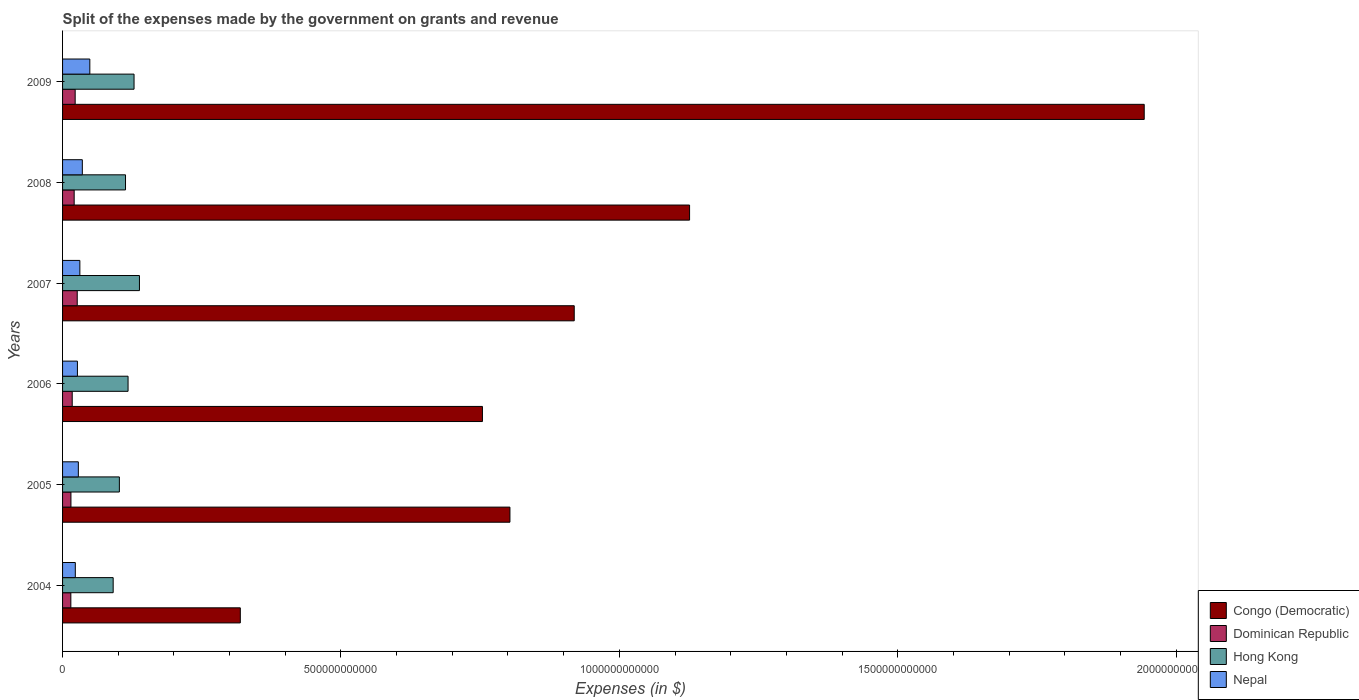How many different coloured bars are there?
Your answer should be compact. 4. How many groups of bars are there?
Provide a short and direct response. 6. How many bars are there on the 1st tick from the top?
Ensure brevity in your answer.  4. How many bars are there on the 6th tick from the bottom?
Your answer should be compact. 4. In how many cases, is the number of bars for a given year not equal to the number of legend labels?
Provide a short and direct response. 0. What is the expenses made by the government on grants and revenue in Nepal in 2009?
Your answer should be very brief. 4.90e+1. Across all years, what is the maximum expenses made by the government on grants and revenue in Congo (Democratic)?
Make the answer very short. 1.94e+12. Across all years, what is the minimum expenses made by the government on grants and revenue in Dominican Republic?
Ensure brevity in your answer.  1.49e+1. In which year was the expenses made by the government on grants and revenue in Hong Kong maximum?
Offer a terse response. 2007. What is the total expenses made by the government on grants and revenue in Hong Kong in the graph?
Provide a succinct answer. 6.90e+11. What is the difference between the expenses made by the government on grants and revenue in Nepal in 2006 and that in 2007?
Your answer should be very brief. -4.39e+09. What is the difference between the expenses made by the government on grants and revenue in Dominican Republic in 2006 and the expenses made by the government on grants and revenue in Congo (Democratic) in 2008?
Offer a terse response. -1.11e+12. What is the average expenses made by the government on grants and revenue in Dominican Republic per year?
Ensure brevity in your answer.  1.95e+1. In the year 2006, what is the difference between the expenses made by the government on grants and revenue in Nepal and expenses made by the government on grants and revenue in Hong Kong?
Keep it short and to the point. -9.10e+1. In how many years, is the expenses made by the government on grants and revenue in Hong Kong greater than 1100000000000 $?
Keep it short and to the point. 0. What is the ratio of the expenses made by the government on grants and revenue in Dominican Republic in 2005 to that in 2008?
Keep it short and to the point. 0.72. What is the difference between the highest and the second highest expenses made by the government on grants and revenue in Nepal?
Offer a terse response. 1.35e+1. What is the difference between the highest and the lowest expenses made by the government on grants and revenue in Nepal?
Offer a terse response. 2.61e+1. Is the sum of the expenses made by the government on grants and revenue in Dominican Republic in 2004 and 2005 greater than the maximum expenses made by the government on grants and revenue in Congo (Democratic) across all years?
Ensure brevity in your answer.  No. What does the 1st bar from the top in 2009 represents?
Ensure brevity in your answer.  Nepal. What does the 3rd bar from the bottom in 2007 represents?
Ensure brevity in your answer.  Hong Kong. Is it the case that in every year, the sum of the expenses made by the government on grants and revenue in Dominican Republic and expenses made by the government on grants and revenue in Nepal is greater than the expenses made by the government on grants and revenue in Congo (Democratic)?
Provide a short and direct response. No. How many bars are there?
Keep it short and to the point. 24. Are all the bars in the graph horizontal?
Your answer should be very brief. Yes. What is the difference between two consecutive major ticks on the X-axis?
Offer a terse response. 5.00e+11. Does the graph contain any zero values?
Your answer should be compact. No. Where does the legend appear in the graph?
Keep it short and to the point. Bottom right. What is the title of the graph?
Keep it short and to the point. Split of the expenses made by the government on grants and revenue. What is the label or title of the X-axis?
Provide a short and direct response. Expenses (in $). What is the Expenses (in $) in Congo (Democratic) in 2004?
Ensure brevity in your answer.  3.19e+11. What is the Expenses (in $) of Dominican Republic in 2004?
Provide a succinct answer. 1.49e+1. What is the Expenses (in $) in Hong Kong in 2004?
Offer a very short reply. 9.09e+1. What is the Expenses (in $) in Nepal in 2004?
Offer a very short reply. 2.29e+1. What is the Expenses (in $) in Congo (Democratic) in 2005?
Provide a short and direct response. 8.04e+11. What is the Expenses (in $) of Dominican Republic in 2005?
Keep it short and to the point. 1.50e+1. What is the Expenses (in $) in Hong Kong in 2005?
Ensure brevity in your answer.  1.02e+11. What is the Expenses (in $) in Nepal in 2005?
Keep it short and to the point. 2.84e+1. What is the Expenses (in $) in Congo (Democratic) in 2006?
Provide a succinct answer. 7.54e+11. What is the Expenses (in $) of Dominican Republic in 2006?
Provide a succinct answer. 1.73e+1. What is the Expenses (in $) in Hong Kong in 2006?
Give a very brief answer. 1.18e+11. What is the Expenses (in $) in Nepal in 2006?
Give a very brief answer. 2.67e+1. What is the Expenses (in $) in Congo (Democratic) in 2007?
Provide a succinct answer. 9.19e+11. What is the Expenses (in $) of Dominican Republic in 2007?
Your answer should be very brief. 2.64e+1. What is the Expenses (in $) of Hong Kong in 2007?
Offer a terse response. 1.38e+11. What is the Expenses (in $) of Nepal in 2007?
Your response must be concise. 3.11e+1. What is the Expenses (in $) of Congo (Democratic) in 2008?
Ensure brevity in your answer.  1.13e+12. What is the Expenses (in $) in Dominican Republic in 2008?
Provide a succinct answer. 2.09e+1. What is the Expenses (in $) of Hong Kong in 2008?
Make the answer very short. 1.13e+11. What is the Expenses (in $) of Nepal in 2008?
Make the answer very short. 3.55e+1. What is the Expenses (in $) in Congo (Democratic) in 2009?
Make the answer very short. 1.94e+12. What is the Expenses (in $) in Dominican Republic in 2009?
Your response must be concise. 2.26e+1. What is the Expenses (in $) in Hong Kong in 2009?
Provide a short and direct response. 1.28e+11. What is the Expenses (in $) in Nepal in 2009?
Provide a short and direct response. 4.90e+1. Across all years, what is the maximum Expenses (in $) in Congo (Democratic)?
Your response must be concise. 1.94e+12. Across all years, what is the maximum Expenses (in $) of Dominican Republic?
Give a very brief answer. 2.64e+1. Across all years, what is the maximum Expenses (in $) of Hong Kong?
Offer a terse response. 1.38e+11. Across all years, what is the maximum Expenses (in $) in Nepal?
Your answer should be compact. 4.90e+1. Across all years, what is the minimum Expenses (in $) of Congo (Democratic)?
Keep it short and to the point. 3.19e+11. Across all years, what is the minimum Expenses (in $) of Dominican Republic?
Offer a very short reply. 1.49e+1. Across all years, what is the minimum Expenses (in $) of Hong Kong?
Your answer should be compact. 9.09e+1. Across all years, what is the minimum Expenses (in $) of Nepal?
Offer a very short reply. 2.29e+1. What is the total Expenses (in $) in Congo (Democratic) in the graph?
Offer a very short reply. 5.86e+12. What is the total Expenses (in $) in Dominican Republic in the graph?
Provide a succinct answer. 1.17e+11. What is the total Expenses (in $) of Hong Kong in the graph?
Provide a short and direct response. 6.90e+11. What is the total Expenses (in $) of Nepal in the graph?
Give a very brief answer. 1.93e+11. What is the difference between the Expenses (in $) in Congo (Democratic) in 2004 and that in 2005?
Offer a very short reply. -4.84e+11. What is the difference between the Expenses (in $) of Dominican Republic in 2004 and that in 2005?
Make the answer very short. -1.70e+08. What is the difference between the Expenses (in $) in Hong Kong in 2004 and that in 2005?
Keep it short and to the point. -1.11e+1. What is the difference between the Expenses (in $) in Nepal in 2004 and that in 2005?
Offer a terse response. -5.46e+09. What is the difference between the Expenses (in $) of Congo (Democratic) in 2004 and that in 2006?
Provide a short and direct response. -4.35e+11. What is the difference between the Expenses (in $) of Dominican Republic in 2004 and that in 2006?
Make the answer very short. -2.48e+09. What is the difference between the Expenses (in $) of Hong Kong in 2004 and that in 2006?
Provide a succinct answer. -2.67e+1. What is the difference between the Expenses (in $) of Nepal in 2004 and that in 2006?
Ensure brevity in your answer.  -3.78e+09. What is the difference between the Expenses (in $) of Congo (Democratic) in 2004 and that in 2007?
Keep it short and to the point. -6.00e+11. What is the difference between the Expenses (in $) of Dominican Republic in 2004 and that in 2007?
Your answer should be compact. -1.15e+1. What is the difference between the Expenses (in $) of Hong Kong in 2004 and that in 2007?
Offer a very short reply. -4.72e+1. What is the difference between the Expenses (in $) in Nepal in 2004 and that in 2007?
Your response must be concise. -8.17e+09. What is the difference between the Expenses (in $) in Congo (Democratic) in 2004 and that in 2008?
Ensure brevity in your answer.  -8.07e+11. What is the difference between the Expenses (in $) in Dominican Republic in 2004 and that in 2008?
Ensure brevity in your answer.  -5.98e+09. What is the difference between the Expenses (in $) of Hong Kong in 2004 and that in 2008?
Offer a very short reply. -2.22e+1. What is the difference between the Expenses (in $) in Nepal in 2004 and that in 2008?
Provide a short and direct response. -1.26e+1. What is the difference between the Expenses (in $) in Congo (Democratic) in 2004 and that in 2009?
Ensure brevity in your answer.  -1.62e+12. What is the difference between the Expenses (in $) in Dominican Republic in 2004 and that in 2009?
Provide a short and direct response. -7.78e+09. What is the difference between the Expenses (in $) in Hong Kong in 2004 and that in 2009?
Ensure brevity in your answer.  -3.75e+1. What is the difference between the Expenses (in $) of Nepal in 2004 and that in 2009?
Provide a short and direct response. -2.61e+1. What is the difference between the Expenses (in $) in Congo (Democratic) in 2005 and that in 2006?
Your answer should be compact. 4.94e+1. What is the difference between the Expenses (in $) of Dominican Republic in 2005 and that in 2006?
Your answer should be compact. -2.31e+09. What is the difference between the Expenses (in $) in Hong Kong in 2005 and that in 2006?
Give a very brief answer. -1.56e+1. What is the difference between the Expenses (in $) of Nepal in 2005 and that in 2006?
Give a very brief answer. 1.68e+09. What is the difference between the Expenses (in $) of Congo (Democratic) in 2005 and that in 2007?
Your response must be concise. -1.15e+11. What is the difference between the Expenses (in $) in Dominican Republic in 2005 and that in 2007?
Offer a terse response. -1.13e+1. What is the difference between the Expenses (in $) in Hong Kong in 2005 and that in 2007?
Provide a succinct answer. -3.61e+1. What is the difference between the Expenses (in $) of Nepal in 2005 and that in 2007?
Make the answer very short. -2.71e+09. What is the difference between the Expenses (in $) of Congo (Democratic) in 2005 and that in 2008?
Provide a succinct answer. -3.23e+11. What is the difference between the Expenses (in $) of Dominican Republic in 2005 and that in 2008?
Provide a succinct answer. -5.81e+09. What is the difference between the Expenses (in $) of Hong Kong in 2005 and that in 2008?
Provide a succinct answer. -1.11e+1. What is the difference between the Expenses (in $) of Nepal in 2005 and that in 2008?
Make the answer very short. -7.14e+09. What is the difference between the Expenses (in $) in Congo (Democratic) in 2005 and that in 2009?
Provide a short and direct response. -1.14e+12. What is the difference between the Expenses (in $) of Dominican Republic in 2005 and that in 2009?
Provide a short and direct response. -7.61e+09. What is the difference between the Expenses (in $) of Hong Kong in 2005 and that in 2009?
Ensure brevity in your answer.  -2.64e+1. What is the difference between the Expenses (in $) in Nepal in 2005 and that in 2009?
Ensure brevity in your answer.  -2.06e+1. What is the difference between the Expenses (in $) of Congo (Democratic) in 2006 and that in 2007?
Keep it short and to the point. -1.65e+11. What is the difference between the Expenses (in $) of Dominican Republic in 2006 and that in 2007?
Your answer should be compact. -9.00e+09. What is the difference between the Expenses (in $) of Hong Kong in 2006 and that in 2007?
Your answer should be very brief. -2.05e+1. What is the difference between the Expenses (in $) of Nepal in 2006 and that in 2007?
Ensure brevity in your answer.  -4.39e+09. What is the difference between the Expenses (in $) in Congo (Democratic) in 2006 and that in 2008?
Provide a succinct answer. -3.72e+11. What is the difference between the Expenses (in $) in Dominican Republic in 2006 and that in 2008?
Your response must be concise. -3.50e+09. What is the difference between the Expenses (in $) of Hong Kong in 2006 and that in 2008?
Offer a very short reply. 4.56e+09. What is the difference between the Expenses (in $) of Nepal in 2006 and that in 2008?
Provide a short and direct response. -8.82e+09. What is the difference between the Expenses (in $) of Congo (Democratic) in 2006 and that in 2009?
Your response must be concise. -1.19e+12. What is the difference between the Expenses (in $) in Dominican Republic in 2006 and that in 2009?
Ensure brevity in your answer.  -5.30e+09. What is the difference between the Expenses (in $) in Hong Kong in 2006 and that in 2009?
Your response must be concise. -1.07e+1. What is the difference between the Expenses (in $) in Nepal in 2006 and that in 2009?
Your answer should be compact. -2.23e+1. What is the difference between the Expenses (in $) in Congo (Democratic) in 2007 and that in 2008?
Give a very brief answer. -2.07e+11. What is the difference between the Expenses (in $) in Dominican Republic in 2007 and that in 2008?
Give a very brief answer. 5.50e+09. What is the difference between the Expenses (in $) in Hong Kong in 2007 and that in 2008?
Provide a short and direct response. 2.50e+1. What is the difference between the Expenses (in $) in Nepal in 2007 and that in 2008?
Your answer should be very brief. -4.43e+09. What is the difference between the Expenses (in $) in Congo (Democratic) in 2007 and that in 2009?
Keep it short and to the point. -1.02e+12. What is the difference between the Expenses (in $) of Dominican Republic in 2007 and that in 2009?
Ensure brevity in your answer.  3.70e+09. What is the difference between the Expenses (in $) in Hong Kong in 2007 and that in 2009?
Make the answer very short. 9.71e+09. What is the difference between the Expenses (in $) of Nepal in 2007 and that in 2009?
Offer a terse response. -1.79e+1. What is the difference between the Expenses (in $) in Congo (Democratic) in 2008 and that in 2009?
Give a very brief answer. -8.17e+11. What is the difference between the Expenses (in $) in Dominican Republic in 2008 and that in 2009?
Ensure brevity in your answer.  -1.80e+09. What is the difference between the Expenses (in $) of Hong Kong in 2008 and that in 2009?
Provide a succinct answer. -1.53e+1. What is the difference between the Expenses (in $) in Nepal in 2008 and that in 2009?
Your answer should be compact. -1.35e+1. What is the difference between the Expenses (in $) of Congo (Democratic) in 2004 and the Expenses (in $) of Dominican Republic in 2005?
Your answer should be compact. 3.04e+11. What is the difference between the Expenses (in $) in Congo (Democratic) in 2004 and the Expenses (in $) in Hong Kong in 2005?
Your response must be concise. 2.17e+11. What is the difference between the Expenses (in $) in Congo (Democratic) in 2004 and the Expenses (in $) in Nepal in 2005?
Your answer should be very brief. 2.91e+11. What is the difference between the Expenses (in $) of Dominican Republic in 2004 and the Expenses (in $) of Hong Kong in 2005?
Your response must be concise. -8.72e+1. What is the difference between the Expenses (in $) of Dominican Republic in 2004 and the Expenses (in $) of Nepal in 2005?
Keep it short and to the point. -1.35e+1. What is the difference between the Expenses (in $) of Hong Kong in 2004 and the Expenses (in $) of Nepal in 2005?
Provide a succinct answer. 6.26e+1. What is the difference between the Expenses (in $) of Congo (Democratic) in 2004 and the Expenses (in $) of Dominican Republic in 2006?
Keep it short and to the point. 3.02e+11. What is the difference between the Expenses (in $) of Congo (Democratic) in 2004 and the Expenses (in $) of Hong Kong in 2006?
Your answer should be very brief. 2.02e+11. What is the difference between the Expenses (in $) in Congo (Democratic) in 2004 and the Expenses (in $) in Nepal in 2006?
Offer a very short reply. 2.93e+11. What is the difference between the Expenses (in $) of Dominican Republic in 2004 and the Expenses (in $) of Hong Kong in 2006?
Your answer should be compact. -1.03e+11. What is the difference between the Expenses (in $) in Dominican Republic in 2004 and the Expenses (in $) in Nepal in 2006?
Provide a short and direct response. -1.18e+1. What is the difference between the Expenses (in $) in Hong Kong in 2004 and the Expenses (in $) in Nepal in 2006?
Your answer should be compact. 6.42e+1. What is the difference between the Expenses (in $) in Congo (Democratic) in 2004 and the Expenses (in $) in Dominican Republic in 2007?
Offer a very short reply. 2.93e+11. What is the difference between the Expenses (in $) of Congo (Democratic) in 2004 and the Expenses (in $) of Hong Kong in 2007?
Give a very brief answer. 1.81e+11. What is the difference between the Expenses (in $) in Congo (Democratic) in 2004 and the Expenses (in $) in Nepal in 2007?
Your answer should be compact. 2.88e+11. What is the difference between the Expenses (in $) in Dominican Republic in 2004 and the Expenses (in $) in Hong Kong in 2007?
Your response must be concise. -1.23e+11. What is the difference between the Expenses (in $) in Dominican Republic in 2004 and the Expenses (in $) in Nepal in 2007?
Ensure brevity in your answer.  -1.62e+1. What is the difference between the Expenses (in $) in Hong Kong in 2004 and the Expenses (in $) in Nepal in 2007?
Your answer should be very brief. 5.98e+1. What is the difference between the Expenses (in $) of Congo (Democratic) in 2004 and the Expenses (in $) of Dominican Republic in 2008?
Your answer should be very brief. 2.98e+11. What is the difference between the Expenses (in $) in Congo (Democratic) in 2004 and the Expenses (in $) in Hong Kong in 2008?
Your answer should be compact. 2.06e+11. What is the difference between the Expenses (in $) in Congo (Democratic) in 2004 and the Expenses (in $) in Nepal in 2008?
Make the answer very short. 2.84e+11. What is the difference between the Expenses (in $) of Dominican Republic in 2004 and the Expenses (in $) of Hong Kong in 2008?
Provide a short and direct response. -9.82e+1. What is the difference between the Expenses (in $) in Dominican Republic in 2004 and the Expenses (in $) in Nepal in 2008?
Provide a short and direct response. -2.06e+1. What is the difference between the Expenses (in $) of Hong Kong in 2004 and the Expenses (in $) of Nepal in 2008?
Your response must be concise. 5.54e+1. What is the difference between the Expenses (in $) of Congo (Democratic) in 2004 and the Expenses (in $) of Dominican Republic in 2009?
Your answer should be compact. 2.97e+11. What is the difference between the Expenses (in $) of Congo (Democratic) in 2004 and the Expenses (in $) of Hong Kong in 2009?
Make the answer very short. 1.91e+11. What is the difference between the Expenses (in $) in Congo (Democratic) in 2004 and the Expenses (in $) in Nepal in 2009?
Keep it short and to the point. 2.70e+11. What is the difference between the Expenses (in $) in Dominican Republic in 2004 and the Expenses (in $) in Hong Kong in 2009?
Provide a succinct answer. -1.14e+11. What is the difference between the Expenses (in $) of Dominican Republic in 2004 and the Expenses (in $) of Nepal in 2009?
Your answer should be very brief. -3.41e+1. What is the difference between the Expenses (in $) of Hong Kong in 2004 and the Expenses (in $) of Nepal in 2009?
Provide a short and direct response. 4.19e+1. What is the difference between the Expenses (in $) in Congo (Democratic) in 2005 and the Expenses (in $) in Dominican Republic in 2006?
Ensure brevity in your answer.  7.86e+11. What is the difference between the Expenses (in $) of Congo (Democratic) in 2005 and the Expenses (in $) of Hong Kong in 2006?
Your response must be concise. 6.86e+11. What is the difference between the Expenses (in $) of Congo (Democratic) in 2005 and the Expenses (in $) of Nepal in 2006?
Keep it short and to the point. 7.77e+11. What is the difference between the Expenses (in $) in Dominican Republic in 2005 and the Expenses (in $) in Hong Kong in 2006?
Provide a succinct answer. -1.03e+11. What is the difference between the Expenses (in $) in Dominican Republic in 2005 and the Expenses (in $) in Nepal in 2006?
Your answer should be very brief. -1.16e+1. What is the difference between the Expenses (in $) in Hong Kong in 2005 and the Expenses (in $) in Nepal in 2006?
Give a very brief answer. 7.53e+1. What is the difference between the Expenses (in $) in Congo (Democratic) in 2005 and the Expenses (in $) in Dominican Republic in 2007?
Provide a short and direct response. 7.77e+11. What is the difference between the Expenses (in $) in Congo (Democratic) in 2005 and the Expenses (in $) in Hong Kong in 2007?
Give a very brief answer. 6.65e+11. What is the difference between the Expenses (in $) of Congo (Democratic) in 2005 and the Expenses (in $) of Nepal in 2007?
Give a very brief answer. 7.72e+11. What is the difference between the Expenses (in $) of Dominican Republic in 2005 and the Expenses (in $) of Hong Kong in 2007?
Make the answer very short. -1.23e+11. What is the difference between the Expenses (in $) in Dominican Republic in 2005 and the Expenses (in $) in Nepal in 2007?
Give a very brief answer. -1.60e+1. What is the difference between the Expenses (in $) in Hong Kong in 2005 and the Expenses (in $) in Nepal in 2007?
Give a very brief answer. 7.10e+1. What is the difference between the Expenses (in $) of Congo (Democratic) in 2005 and the Expenses (in $) of Dominican Republic in 2008?
Your answer should be very brief. 7.83e+11. What is the difference between the Expenses (in $) of Congo (Democratic) in 2005 and the Expenses (in $) of Hong Kong in 2008?
Make the answer very short. 6.90e+11. What is the difference between the Expenses (in $) in Congo (Democratic) in 2005 and the Expenses (in $) in Nepal in 2008?
Offer a terse response. 7.68e+11. What is the difference between the Expenses (in $) in Dominican Republic in 2005 and the Expenses (in $) in Hong Kong in 2008?
Your answer should be very brief. -9.80e+1. What is the difference between the Expenses (in $) of Dominican Republic in 2005 and the Expenses (in $) of Nepal in 2008?
Keep it short and to the point. -2.05e+1. What is the difference between the Expenses (in $) of Hong Kong in 2005 and the Expenses (in $) of Nepal in 2008?
Offer a terse response. 6.65e+1. What is the difference between the Expenses (in $) of Congo (Democratic) in 2005 and the Expenses (in $) of Dominican Republic in 2009?
Provide a short and direct response. 7.81e+11. What is the difference between the Expenses (in $) of Congo (Democratic) in 2005 and the Expenses (in $) of Hong Kong in 2009?
Keep it short and to the point. 6.75e+11. What is the difference between the Expenses (in $) in Congo (Democratic) in 2005 and the Expenses (in $) in Nepal in 2009?
Offer a very short reply. 7.55e+11. What is the difference between the Expenses (in $) of Dominican Republic in 2005 and the Expenses (in $) of Hong Kong in 2009?
Keep it short and to the point. -1.13e+11. What is the difference between the Expenses (in $) of Dominican Republic in 2005 and the Expenses (in $) of Nepal in 2009?
Ensure brevity in your answer.  -3.39e+1. What is the difference between the Expenses (in $) in Hong Kong in 2005 and the Expenses (in $) in Nepal in 2009?
Provide a succinct answer. 5.30e+1. What is the difference between the Expenses (in $) in Congo (Democratic) in 2006 and the Expenses (in $) in Dominican Republic in 2007?
Give a very brief answer. 7.28e+11. What is the difference between the Expenses (in $) in Congo (Democratic) in 2006 and the Expenses (in $) in Hong Kong in 2007?
Provide a short and direct response. 6.16e+11. What is the difference between the Expenses (in $) in Congo (Democratic) in 2006 and the Expenses (in $) in Nepal in 2007?
Your response must be concise. 7.23e+11. What is the difference between the Expenses (in $) in Dominican Republic in 2006 and the Expenses (in $) in Hong Kong in 2007?
Offer a terse response. -1.21e+11. What is the difference between the Expenses (in $) in Dominican Republic in 2006 and the Expenses (in $) in Nepal in 2007?
Provide a succinct answer. -1.37e+1. What is the difference between the Expenses (in $) in Hong Kong in 2006 and the Expenses (in $) in Nepal in 2007?
Provide a short and direct response. 8.66e+1. What is the difference between the Expenses (in $) of Congo (Democratic) in 2006 and the Expenses (in $) of Dominican Republic in 2008?
Give a very brief answer. 7.33e+11. What is the difference between the Expenses (in $) in Congo (Democratic) in 2006 and the Expenses (in $) in Hong Kong in 2008?
Offer a terse response. 6.41e+11. What is the difference between the Expenses (in $) of Congo (Democratic) in 2006 and the Expenses (in $) of Nepal in 2008?
Offer a very short reply. 7.19e+11. What is the difference between the Expenses (in $) of Dominican Republic in 2006 and the Expenses (in $) of Hong Kong in 2008?
Provide a short and direct response. -9.57e+1. What is the difference between the Expenses (in $) of Dominican Republic in 2006 and the Expenses (in $) of Nepal in 2008?
Offer a very short reply. -1.81e+1. What is the difference between the Expenses (in $) in Hong Kong in 2006 and the Expenses (in $) in Nepal in 2008?
Offer a very short reply. 8.21e+1. What is the difference between the Expenses (in $) of Congo (Democratic) in 2006 and the Expenses (in $) of Dominican Republic in 2009?
Ensure brevity in your answer.  7.31e+11. What is the difference between the Expenses (in $) of Congo (Democratic) in 2006 and the Expenses (in $) of Hong Kong in 2009?
Ensure brevity in your answer.  6.26e+11. What is the difference between the Expenses (in $) of Congo (Democratic) in 2006 and the Expenses (in $) of Nepal in 2009?
Provide a succinct answer. 7.05e+11. What is the difference between the Expenses (in $) in Dominican Republic in 2006 and the Expenses (in $) in Hong Kong in 2009?
Provide a succinct answer. -1.11e+11. What is the difference between the Expenses (in $) of Dominican Republic in 2006 and the Expenses (in $) of Nepal in 2009?
Provide a short and direct response. -3.16e+1. What is the difference between the Expenses (in $) of Hong Kong in 2006 and the Expenses (in $) of Nepal in 2009?
Offer a very short reply. 6.87e+1. What is the difference between the Expenses (in $) of Congo (Democratic) in 2007 and the Expenses (in $) of Dominican Republic in 2008?
Give a very brief answer. 8.98e+11. What is the difference between the Expenses (in $) of Congo (Democratic) in 2007 and the Expenses (in $) of Hong Kong in 2008?
Keep it short and to the point. 8.06e+11. What is the difference between the Expenses (in $) of Congo (Democratic) in 2007 and the Expenses (in $) of Nepal in 2008?
Make the answer very short. 8.84e+11. What is the difference between the Expenses (in $) of Dominican Republic in 2007 and the Expenses (in $) of Hong Kong in 2008?
Your answer should be compact. -8.67e+1. What is the difference between the Expenses (in $) of Dominican Republic in 2007 and the Expenses (in $) of Nepal in 2008?
Provide a short and direct response. -9.14e+09. What is the difference between the Expenses (in $) of Hong Kong in 2007 and the Expenses (in $) of Nepal in 2008?
Keep it short and to the point. 1.03e+11. What is the difference between the Expenses (in $) in Congo (Democratic) in 2007 and the Expenses (in $) in Dominican Republic in 2009?
Your response must be concise. 8.96e+11. What is the difference between the Expenses (in $) of Congo (Democratic) in 2007 and the Expenses (in $) of Hong Kong in 2009?
Your answer should be very brief. 7.91e+11. What is the difference between the Expenses (in $) of Congo (Democratic) in 2007 and the Expenses (in $) of Nepal in 2009?
Your answer should be very brief. 8.70e+11. What is the difference between the Expenses (in $) of Dominican Republic in 2007 and the Expenses (in $) of Hong Kong in 2009?
Give a very brief answer. -1.02e+11. What is the difference between the Expenses (in $) of Dominican Republic in 2007 and the Expenses (in $) of Nepal in 2009?
Make the answer very short. -2.26e+1. What is the difference between the Expenses (in $) in Hong Kong in 2007 and the Expenses (in $) in Nepal in 2009?
Your answer should be very brief. 8.91e+1. What is the difference between the Expenses (in $) in Congo (Democratic) in 2008 and the Expenses (in $) in Dominican Republic in 2009?
Provide a succinct answer. 1.10e+12. What is the difference between the Expenses (in $) in Congo (Democratic) in 2008 and the Expenses (in $) in Hong Kong in 2009?
Give a very brief answer. 9.98e+11. What is the difference between the Expenses (in $) in Congo (Democratic) in 2008 and the Expenses (in $) in Nepal in 2009?
Your answer should be compact. 1.08e+12. What is the difference between the Expenses (in $) of Dominican Republic in 2008 and the Expenses (in $) of Hong Kong in 2009?
Make the answer very short. -1.08e+11. What is the difference between the Expenses (in $) of Dominican Republic in 2008 and the Expenses (in $) of Nepal in 2009?
Provide a short and direct response. -2.81e+1. What is the difference between the Expenses (in $) of Hong Kong in 2008 and the Expenses (in $) of Nepal in 2009?
Offer a terse response. 6.41e+1. What is the average Expenses (in $) in Congo (Democratic) per year?
Your answer should be compact. 9.77e+11. What is the average Expenses (in $) of Dominican Republic per year?
Your response must be concise. 1.95e+1. What is the average Expenses (in $) in Hong Kong per year?
Offer a terse response. 1.15e+11. What is the average Expenses (in $) in Nepal per year?
Keep it short and to the point. 3.22e+1. In the year 2004, what is the difference between the Expenses (in $) of Congo (Democratic) and Expenses (in $) of Dominican Republic?
Ensure brevity in your answer.  3.04e+11. In the year 2004, what is the difference between the Expenses (in $) of Congo (Democratic) and Expenses (in $) of Hong Kong?
Offer a terse response. 2.28e+11. In the year 2004, what is the difference between the Expenses (in $) in Congo (Democratic) and Expenses (in $) in Nepal?
Offer a very short reply. 2.96e+11. In the year 2004, what is the difference between the Expenses (in $) in Dominican Republic and Expenses (in $) in Hong Kong?
Offer a terse response. -7.60e+1. In the year 2004, what is the difference between the Expenses (in $) of Dominican Republic and Expenses (in $) of Nepal?
Make the answer very short. -8.02e+09. In the year 2004, what is the difference between the Expenses (in $) in Hong Kong and Expenses (in $) in Nepal?
Your answer should be compact. 6.80e+1. In the year 2005, what is the difference between the Expenses (in $) of Congo (Democratic) and Expenses (in $) of Dominican Republic?
Keep it short and to the point. 7.88e+11. In the year 2005, what is the difference between the Expenses (in $) of Congo (Democratic) and Expenses (in $) of Hong Kong?
Give a very brief answer. 7.02e+11. In the year 2005, what is the difference between the Expenses (in $) of Congo (Democratic) and Expenses (in $) of Nepal?
Give a very brief answer. 7.75e+11. In the year 2005, what is the difference between the Expenses (in $) in Dominican Republic and Expenses (in $) in Hong Kong?
Give a very brief answer. -8.70e+1. In the year 2005, what is the difference between the Expenses (in $) in Dominican Republic and Expenses (in $) in Nepal?
Provide a short and direct response. -1.33e+1. In the year 2005, what is the difference between the Expenses (in $) in Hong Kong and Expenses (in $) in Nepal?
Offer a very short reply. 7.37e+1. In the year 2006, what is the difference between the Expenses (in $) of Congo (Democratic) and Expenses (in $) of Dominican Republic?
Make the answer very short. 7.37e+11. In the year 2006, what is the difference between the Expenses (in $) of Congo (Democratic) and Expenses (in $) of Hong Kong?
Keep it short and to the point. 6.36e+11. In the year 2006, what is the difference between the Expenses (in $) of Congo (Democratic) and Expenses (in $) of Nepal?
Your response must be concise. 7.27e+11. In the year 2006, what is the difference between the Expenses (in $) of Dominican Republic and Expenses (in $) of Hong Kong?
Provide a short and direct response. -1.00e+11. In the year 2006, what is the difference between the Expenses (in $) of Dominican Republic and Expenses (in $) of Nepal?
Your answer should be compact. -9.32e+09. In the year 2006, what is the difference between the Expenses (in $) of Hong Kong and Expenses (in $) of Nepal?
Ensure brevity in your answer.  9.10e+1. In the year 2007, what is the difference between the Expenses (in $) in Congo (Democratic) and Expenses (in $) in Dominican Republic?
Ensure brevity in your answer.  8.93e+11. In the year 2007, what is the difference between the Expenses (in $) of Congo (Democratic) and Expenses (in $) of Hong Kong?
Keep it short and to the point. 7.81e+11. In the year 2007, what is the difference between the Expenses (in $) of Congo (Democratic) and Expenses (in $) of Nepal?
Keep it short and to the point. 8.88e+11. In the year 2007, what is the difference between the Expenses (in $) of Dominican Republic and Expenses (in $) of Hong Kong?
Ensure brevity in your answer.  -1.12e+11. In the year 2007, what is the difference between the Expenses (in $) in Dominican Republic and Expenses (in $) in Nepal?
Your answer should be compact. -4.71e+09. In the year 2007, what is the difference between the Expenses (in $) in Hong Kong and Expenses (in $) in Nepal?
Keep it short and to the point. 1.07e+11. In the year 2008, what is the difference between the Expenses (in $) of Congo (Democratic) and Expenses (in $) of Dominican Republic?
Offer a terse response. 1.11e+12. In the year 2008, what is the difference between the Expenses (in $) of Congo (Democratic) and Expenses (in $) of Hong Kong?
Your answer should be compact. 1.01e+12. In the year 2008, what is the difference between the Expenses (in $) of Congo (Democratic) and Expenses (in $) of Nepal?
Your answer should be compact. 1.09e+12. In the year 2008, what is the difference between the Expenses (in $) in Dominican Republic and Expenses (in $) in Hong Kong?
Offer a terse response. -9.22e+1. In the year 2008, what is the difference between the Expenses (in $) of Dominican Republic and Expenses (in $) of Nepal?
Make the answer very short. -1.46e+1. In the year 2008, what is the difference between the Expenses (in $) in Hong Kong and Expenses (in $) in Nepal?
Keep it short and to the point. 7.76e+1. In the year 2009, what is the difference between the Expenses (in $) of Congo (Democratic) and Expenses (in $) of Dominican Republic?
Your answer should be compact. 1.92e+12. In the year 2009, what is the difference between the Expenses (in $) of Congo (Democratic) and Expenses (in $) of Hong Kong?
Provide a short and direct response. 1.81e+12. In the year 2009, what is the difference between the Expenses (in $) of Congo (Democratic) and Expenses (in $) of Nepal?
Ensure brevity in your answer.  1.89e+12. In the year 2009, what is the difference between the Expenses (in $) of Dominican Republic and Expenses (in $) of Hong Kong?
Keep it short and to the point. -1.06e+11. In the year 2009, what is the difference between the Expenses (in $) of Dominican Republic and Expenses (in $) of Nepal?
Offer a very short reply. -2.63e+1. In the year 2009, what is the difference between the Expenses (in $) in Hong Kong and Expenses (in $) in Nepal?
Give a very brief answer. 7.94e+1. What is the ratio of the Expenses (in $) in Congo (Democratic) in 2004 to that in 2005?
Give a very brief answer. 0.4. What is the ratio of the Expenses (in $) in Dominican Republic in 2004 to that in 2005?
Provide a succinct answer. 0.99. What is the ratio of the Expenses (in $) of Hong Kong in 2004 to that in 2005?
Keep it short and to the point. 0.89. What is the ratio of the Expenses (in $) of Nepal in 2004 to that in 2005?
Provide a short and direct response. 0.81. What is the ratio of the Expenses (in $) in Congo (Democratic) in 2004 to that in 2006?
Your answer should be very brief. 0.42. What is the ratio of the Expenses (in $) of Dominican Republic in 2004 to that in 2006?
Keep it short and to the point. 0.86. What is the ratio of the Expenses (in $) in Hong Kong in 2004 to that in 2006?
Keep it short and to the point. 0.77. What is the ratio of the Expenses (in $) in Nepal in 2004 to that in 2006?
Your response must be concise. 0.86. What is the ratio of the Expenses (in $) of Congo (Democratic) in 2004 to that in 2007?
Keep it short and to the point. 0.35. What is the ratio of the Expenses (in $) of Dominican Republic in 2004 to that in 2007?
Your answer should be compact. 0.56. What is the ratio of the Expenses (in $) in Hong Kong in 2004 to that in 2007?
Give a very brief answer. 0.66. What is the ratio of the Expenses (in $) in Nepal in 2004 to that in 2007?
Your response must be concise. 0.74. What is the ratio of the Expenses (in $) of Congo (Democratic) in 2004 to that in 2008?
Ensure brevity in your answer.  0.28. What is the ratio of the Expenses (in $) of Dominican Republic in 2004 to that in 2008?
Your answer should be very brief. 0.71. What is the ratio of the Expenses (in $) in Hong Kong in 2004 to that in 2008?
Your answer should be compact. 0.8. What is the ratio of the Expenses (in $) in Nepal in 2004 to that in 2008?
Offer a very short reply. 0.64. What is the ratio of the Expenses (in $) in Congo (Democratic) in 2004 to that in 2009?
Your answer should be compact. 0.16. What is the ratio of the Expenses (in $) of Dominican Republic in 2004 to that in 2009?
Your response must be concise. 0.66. What is the ratio of the Expenses (in $) in Hong Kong in 2004 to that in 2009?
Give a very brief answer. 0.71. What is the ratio of the Expenses (in $) in Nepal in 2004 to that in 2009?
Provide a succinct answer. 0.47. What is the ratio of the Expenses (in $) in Congo (Democratic) in 2005 to that in 2006?
Provide a succinct answer. 1.07. What is the ratio of the Expenses (in $) in Dominican Republic in 2005 to that in 2006?
Offer a very short reply. 0.87. What is the ratio of the Expenses (in $) in Hong Kong in 2005 to that in 2006?
Ensure brevity in your answer.  0.87. What is the ratio of the Expenses (in $) in Nepal in 2005 to that in 2006?
Your response must be concise. 1.06. What is the ratio of the Expenses (in $) of Congo (Democratic) in 2005 to that in 2007?
Ensure brevity in your answer.  0.87. What is the ratio of the Expenses (in $) in Dominican Republic in 2005 to that in 2007?
Your response must be concise. 0.57. What is the ratio of the Expenses (in $) of Hong Kong in 2005 to that in 2007?
Offer a terse response. 0.74. What is the ratio of the Expenses (in $) in Nepal in 2005 to that in 2007?
Make the answer very short. 0.91. What is the ratio of the Expenses (in $) of Congo (Democratic) in 2005 to that in 2008?
Your answer should be compact. 0.71. What is the ratio of the Expenses (in $) of Dominican Republic in 2005 to that in 2008?
Your response must be concise. 0.72. What is the ratio of the Expenses (in $) of Hong Kong in 2005 to that in 2008?
Ensure brevity in your answer.  0.9. What is the ratio of the Expenses (in $) of Nepal in 2005 to that in 2008?
Offer a terse response. 0.8. What is the ratio of the Expenses (in $) of Congo (Democratic) in 2005 to that in 2009?
Offer a terse response. 0.41. What is the ratio of the Expenses (in $) of Dominican Republic in 2005 to that in 2009?
Your answer should be compact. 0.66. What is the ratio of the Expenses (in $) of Hong Kong in 2005 to that in 2009?
Provide a succinct answer. 0.79. What is the ratio of the Expenses (in $) in Nepal in 2005 to that in 2009?
Provide a succinct answer. 0.58. What is the ratio of the Expenses (in $) of Congo (Democratic) in 2006 to that in 2007?
Keep it short and to the point. 0.82. What is the ratio of the Expenses (in $) in Dominican Republic in 2006 to that in 2007?
Ensure brevity in your answer.  0.66. What is the ratio of the Expenses (in $) in Hong Kong in 2006 to that in 2007?
Ensure brevity in your answer.  0.85. What is the ratio of the Expenses (in $) in Nepal in 2006 to that in 2007?
Provide a succinct answer. 0.86. What is the ratio of the Expenses (in $) of Congo (Democratic) in 2006 to that in 2008?
Ensure brevity in your answer.  0.67. What is the ratio of the Expenses (in $) in Dominican Republic in 2006 to that in 2008?
Provide a short and direct response. 0.83. What is the ratio of the Expenses (in $) in Hong Kong in 2006 to that in 2008?
Keep it short and to the point. 1.04. What is the ratio of the Expenses (in $) in Nepal in 2006 to that in 2008?
Ensure brevity in your answer.  0.75. What is the ratio of the Expenses (in $) of Congo (Democratic) in 2006 to that in 2009?
Your answer should be compact. 0.39. What is the ratio of the Expenses (in $) of Dominican Republic in 2006 to that in 2009?
Give a very brief answer. 0.77. What is the ratio of the Expenses (in $) in Hong Kong in 2006 to that in 2009?
Offer a very short reply. 0.92. What is the ratio of the Expenses (in $) in Nepal in 2006 to that in 2009?
Your response must be concise. 0.54. What is the ratio of the Expenses (in $) of Congo (Democratic) in 2007 to that in 2008?
Your response must be concise. 0.82. What is the ratio of the Expenses (in $) in Dominican Republic in 2007 to that in 2008?
Your answer should be very brief. 1.26. What is the ratio of the Expenses (in $) of Hong Kong in 2007 to that in 2008?
Offer a very short reply. 1.22. What is the ratio of the Expenses (in $) of Nepal in 2007 to that in 2008?
Make the answer very short. 0.88. What is the ratio of the Expenses (in $) in Congo (Democratic) in 2007 to that in 2009?
Ensure brevity in your answer.  0.47. What is the ratio of the Expenses (in $) in Dominican Republic in 2007 to that in 2009?
Provide a succinct answer. 1.16. What is the ratio of the Expenses (in $) of Hong Kong in 2007 to that in 2009?
Provide a succinct answer. 1.08. What is the ratio of the Expenses (in $) in Nepal in 2007 to that in 2009?
Your answer should be very brief. 0.63. What is the ratio of the Expenses (in $) of Congo (Democratic) in 2008 to that in 2009?
Your answer should be compact. 0.58. What is the ratio of the Expenses (in $) of Dominican Republic in 2008 to that in 2009?
Make the answer very short. 0.92. What is the ratio of the Expenses (in $) in Hong Kong in 2008 to that in 2009?
Give a very brief answer. 0.88. What is the ratio of the Expenses (in $) of Nepal in 2008 to that in 2009?
Ensure brevity in your answer.  0.72. What is the difference between the highest and the second highest Expenses (in $) of Congo (Democratic)?
Provide a succinct answer. 8.17e+11. What is the difference between the highest and the second highest Expenses (in $) of Dominican Republic?
Your response must be concise. 3.70e+09. What is the difference between the highest and the second highest Expenses (in $) of Hong Kong?
Make the answer very short. 9.71e+09. What is the difference between the highest and the second highest Expenses (in $) of Nepal?
Provide a short and direct response. 1.35e+1. What is the difference between the highest and the lowest Expenses (in $) in Congo (Democratic)?
Your response must be concise. 1.62e+12. What is the difference between the highest and the lowest Expenses (in $) in Dominican Republic?
Your answer should be very brief. 1.15e+1. What is the difference between the highest and the lowest Expenses (in $) of Hong Kong?
Your answer should be compact. 4.72e+1. What is the difference between the highest and the lowest Expenses (in $) in Nepal?
Make the answer very short. 2.61e+1. 